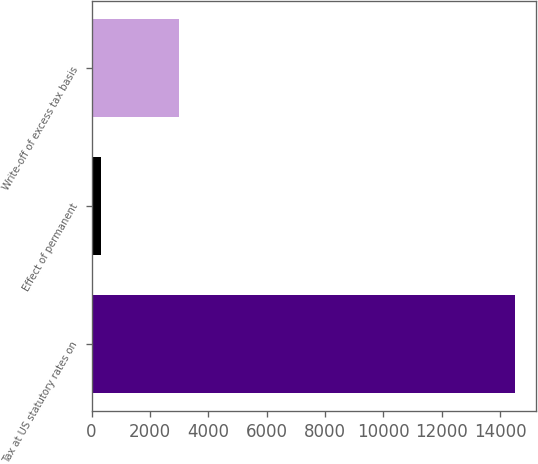Convert chart. <chart><loc_0><loc_0><loc_500><loc_500><bar_chart><fcel>Tax at US statutory rates on<fcel>Effect of permanent<fcel>Write-off of excess tax basis<nl><fcel>14508<fcel>306<fcel>2983<nl></chart> 